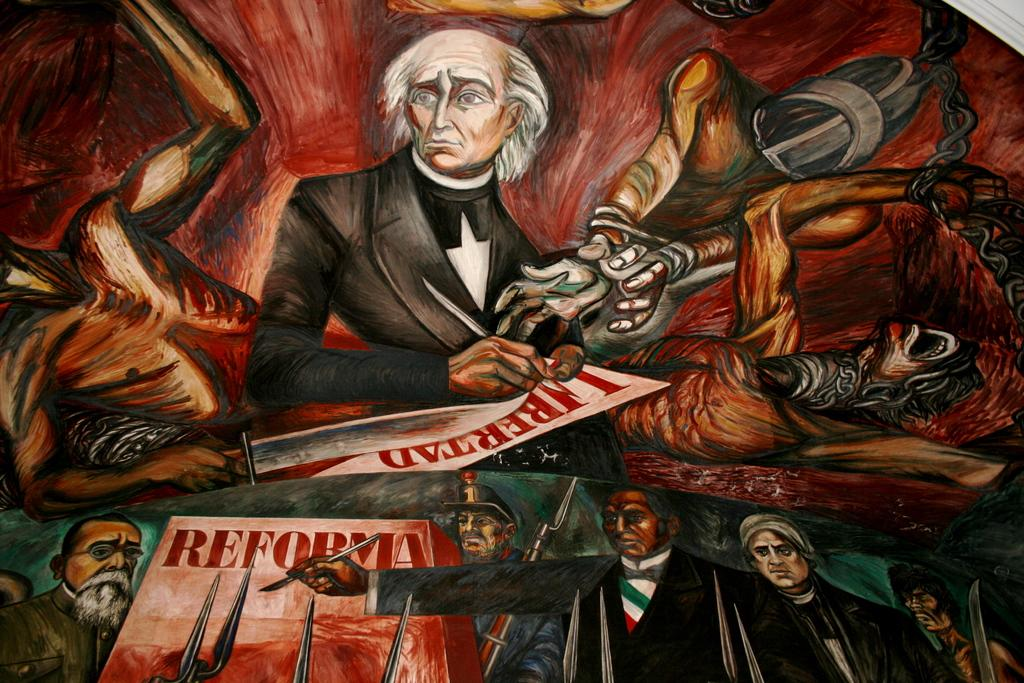<image>
Offer a succinct explanation of the picture presented. A painting features a group of men and the word Reforma. 